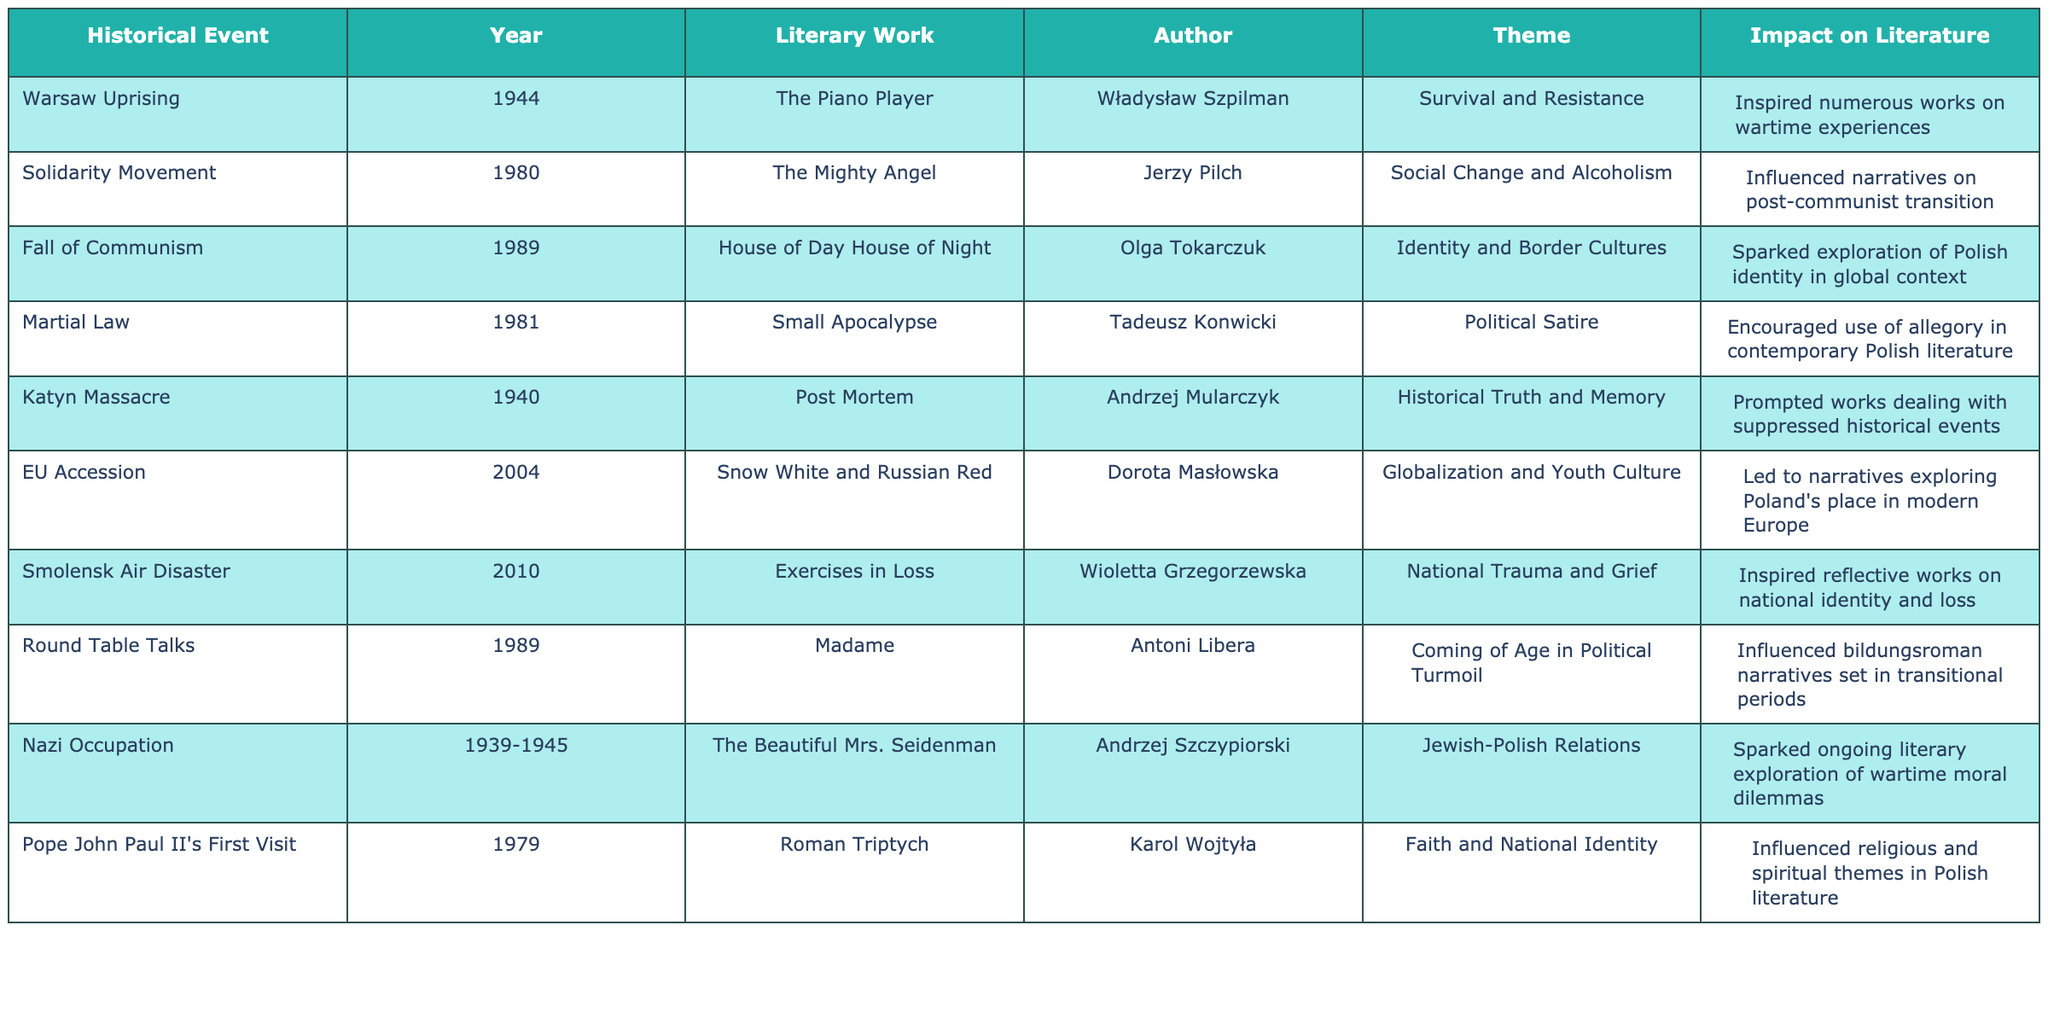What literary work discusses the theme of survival and resistance? The table indicates that "The Piano Player" by Władysław Szpilman addresses the theme of survival and resistance, linked to the Warsaw Uprising in 1944.
Answer: The Piano Player Which author wrote about the influence of the Solidarity Movement on narratives of post-communist transition? According to the table, Jerzy Pilch's literary work, "The Mighty Angel," is connected to the Solidarity Movement and explores themes of social change and alcoholism.
Answer: Jerzy Pilch How many historical events are linked to works by Olga Tokarczuk? The table shows that Olga Tokarczuk's work, "House of Day House of Night," is connected to one historical event, which is the fall of communism in 1989.
Answer: One Did the Katyn Massacre result in literature focused on historical truth and memory? The table confirms that the Katyn Massacre prompted works dealing with suppressed historical events, focusing on themes of historical truth and memory.
Answer: Yes What is the impact of the Smolensk Air Disaster on contemporary Polish literature? The table indicates that the Smolensk Air Disaster inspired reflective works on themes of national identity and grief, suggesting its significant impact on contemporary literature.
Answer: Reflective works on national identity and grief Which theme recurs in literary works stemming from the Nazi occupation? The table reveals that Jewish-Polish relations are a recurring theme in works about the Nazi occupation, as exemplified by "The Beautiful Mrs. Seidenman" by Andrzej Szczypiorski.
Answer: Jewish-Polish relations What is the difference between the themes explored in "Small Apocalypse" and "Exercises in Loss"? "Small Apocalypse" by Tadeusz Konwicki explores political satire, while "Exercises in Loss" by Wioletta Grzegorzewska focuses on national trauma and grief, indicating a thematic difference in political critique versus emotional reflection.
Answer: Political satire vs. national trauma How many literary works in the table are associated with the year 1989? The table lists two works associated with 1989: "House of Day House of Night" by Olga Tokarczuk related to the fall of communism, and "Madame" by Antoni Libera linked to the Round Table Talks.
Answer: Two Which author contributed to literature addressing globalization and youth culture? The analysis of the table confirms that Dorota Masłowska's work, "Snow White and Russian Red," addresses themes of globalization and youth culture.
Answer: Dorota Masłowska Which theme is linked to Pope John Paul II's first visit to Poland? The table indicates that the theme of faith and national identity is linked to the literary work "Roman Triptych" by Karol Wojtyła.
Answer: Faith and national identity 